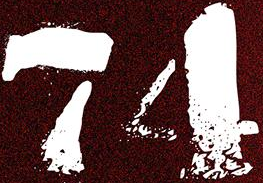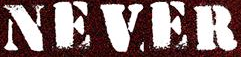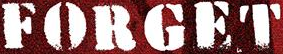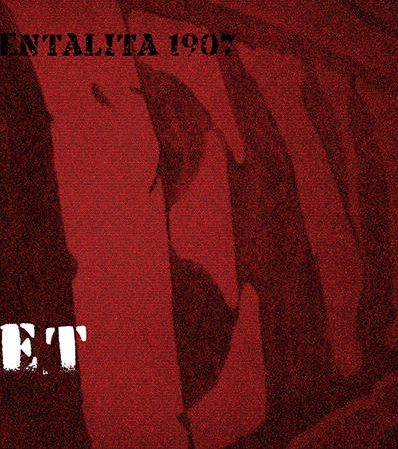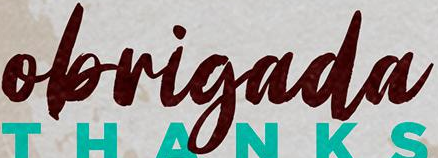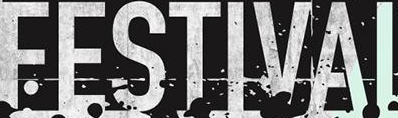Read the text content from these images in order, separated by a semicolon. 74; NEVER; FORGET; EV; obrigada; FESTIVAI 